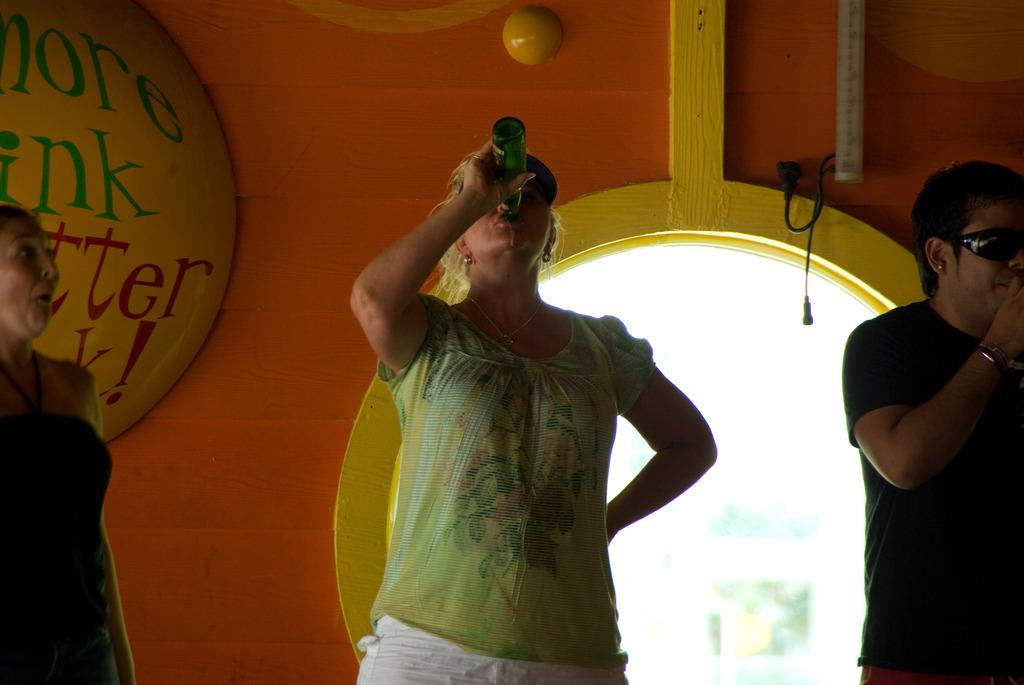How many people are in the image? There are three people in the image. What is one of the women holding? One woman is holding a bottle. What can be seen in the background of the image? There is a wall and objects visible in the background of the image. How does the engine in the image contribute to the scene? There is no engine present in the image. What is the relationship between the people in the image and the woman's sister? The facts provided do not mention a sister, so we cannot determine the relationship between the people in the image and a sister. 